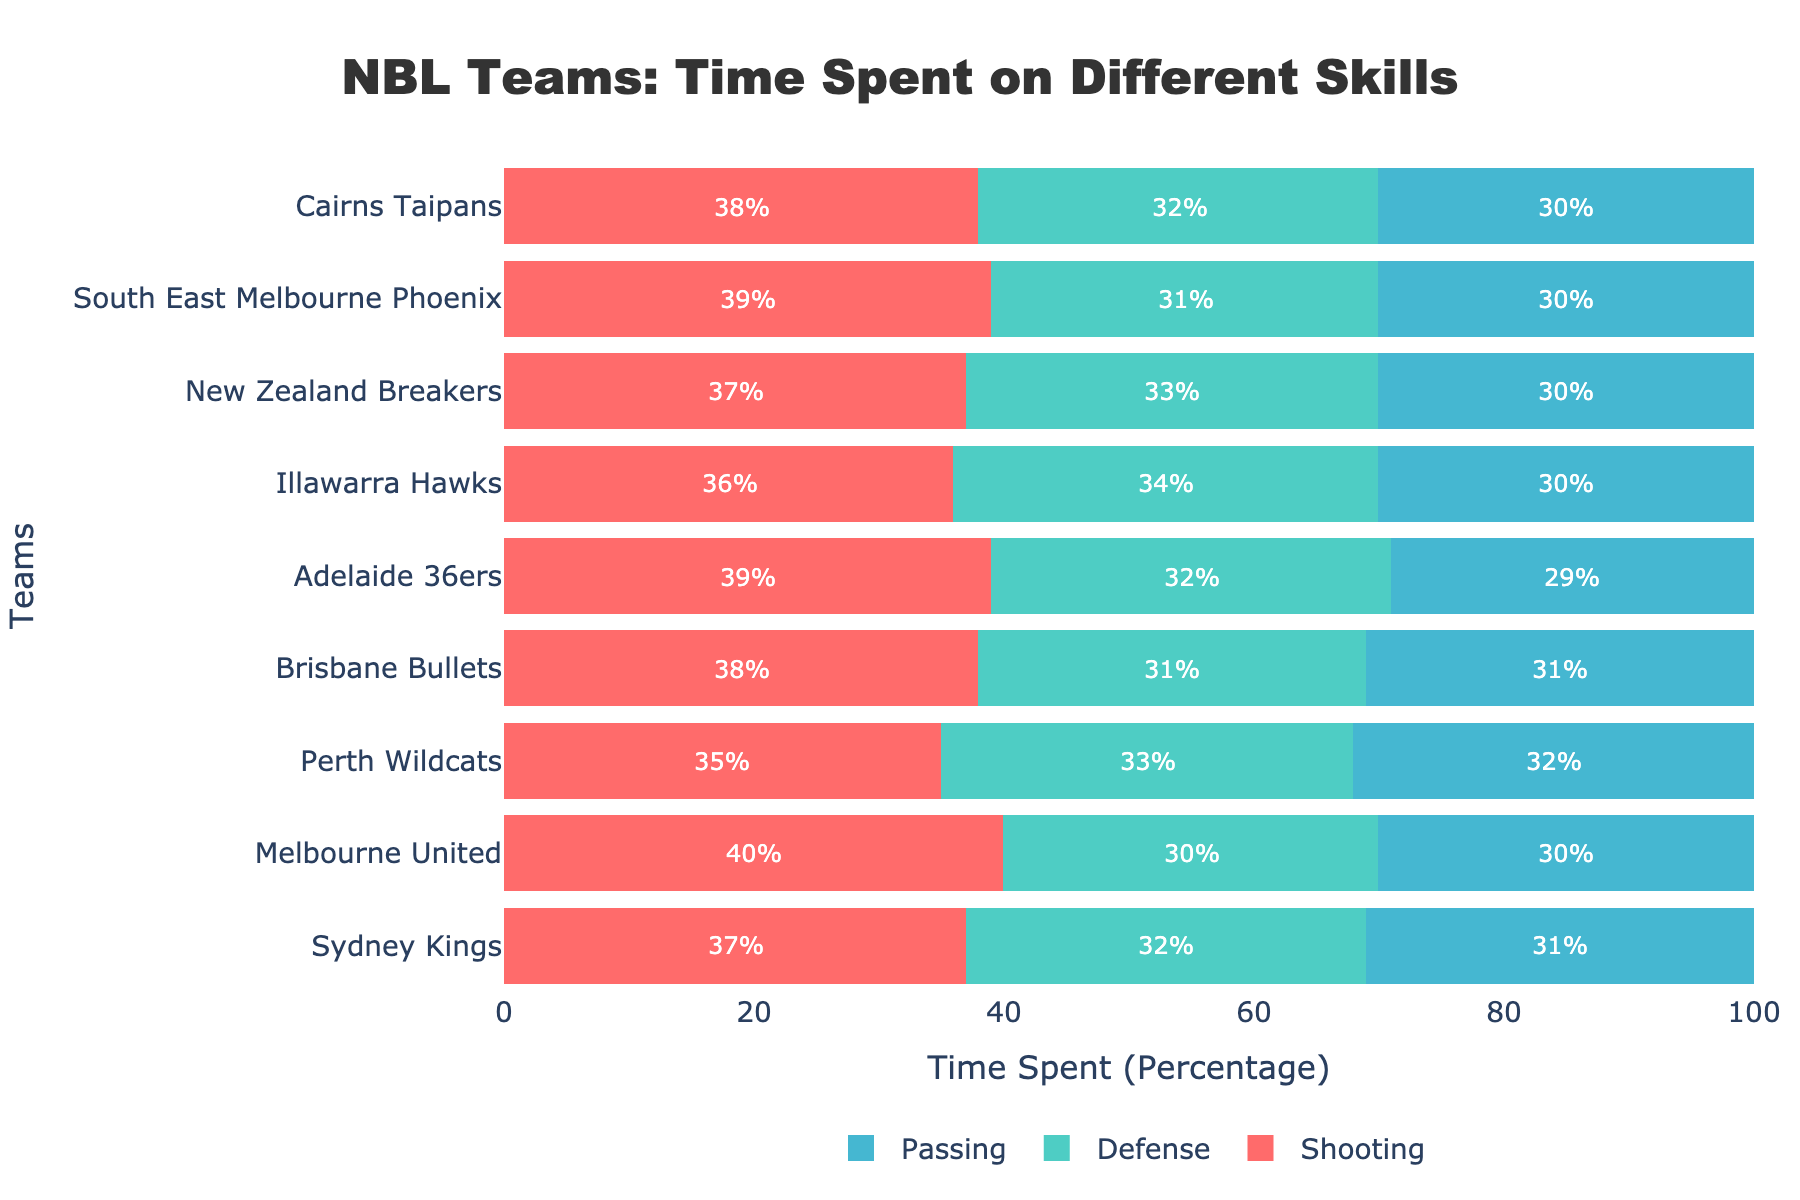What's the team with the highest percentage of time spent on shooting? To determine which team spends the highest percentage of their time on shooting, we need to compare the shooting percentages for all teams. Sydney Kings: 37%, Melbourne United: 40%, Perth Wildcats: 35%, Brisbane Bullets: 38%, Adelaide 36ers: 39%, Illawarra Hawks: 36%, New Zealand Breakers: 37%, South East Melbourne Phoenix: 39%, Cairns Taipans: 38%. The highest is Melbourne United with 40%.
Answer: Melbourne United Which team spends the least amount of time on defense? We need to compare the defense percentages for all teams. Sydney Kings: 32%, Melbourne United: 30%, Perth Wildcats: 33%, Brisbane Bullets: 31%, Adelaide 36ers: 32%, Illawarra Hawks: 34%, New Zealand Breakers: 33%, South East Melbourne Phoenix: 31%, Cairns Taipans: 32%. The lowest is Melbourne United with 30%.
Answer: Melbourne United How much more time does the Illawarra Hawks spend on defense compared to passing? We need to find the difference between the defense and passing percentages for Illawarra Hawks. Defense: 34%, Passing: 30%. So, the difference is 34% - 30% = 4%.
Answer: 4% Which team has an equal distribution of time on two skills and what are those skills? We need to find if any team has the same percentage in two of the three categories. Brisbane Bullets and Cairns Taipans both have 31% in Shooting and Passing.
Answer: Brisbane Bullets and Cairns Taipans (Shooting, Passing) What is the combined percentage of time spent on skills other than shooting for the Adelaide 36ers? We need to sum the percentages of Defense and Passing for Adelaide 36ers. Defense: 32%, Passing: 29%. So, the combined percentage is 32% + 29% = 61%.
Answer: 61% Compare the time spent on defense by Perth Wildcats and Illawarra Hawks. Which team spends more, and by how much? To compare, we subtract the defense percentage of Perth Wildcats from Illawarra Hawks. Defense for Perth Wildcats: 33%, Illawarra Hawks: 34%. The difference is 34% - 33% = 1%, so Illawarra Hawks spend more by 1%.
Answer: Illawarra Hawks, 1% What is the average percentage of time spent on passing for all teams? To find the average, sum the passing percentages for all teams and divide by the number of teams. Passing percentages: 31, 30, 32, 31, 29, 30, 30, 30, 30. Sum = 243. Number of teams = 9. Average = 243 / 9 = 27.
Answer: 27% What's the most common percentage value for time spent on passing among the teams? We need to observe the frequencies of the passing percentages. The passing values are: 31, 30, 32, 31, 29, 30, 30, 30, 30. The most frequent value is 30%.
Answer: 30% Which  teams have a combined percentage of Shooting and Defense exceeding 70%? We need to sum the Shooting and Defense percentages and see which ones are over 70%. Exceeding 70%: Melbourne United (40+30=70), Adelaide 36ers (39+32=71), Illawarra Hawks (36+34=70).
Answer: Adelaide 36ers What is the total percentage distribution for shooting among all teams combined? To calculate the total, sum the shooting percentages for all teams. Shooting percentages: 37, 40, 35, 38, 39, 36, 37, 39, 38. Sum = 339%.
Answer: 339% 